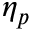Convert formula to latex. <formula><loc_0><loc_0><loc_500><loc_500>\eta _ { p }</formula> 